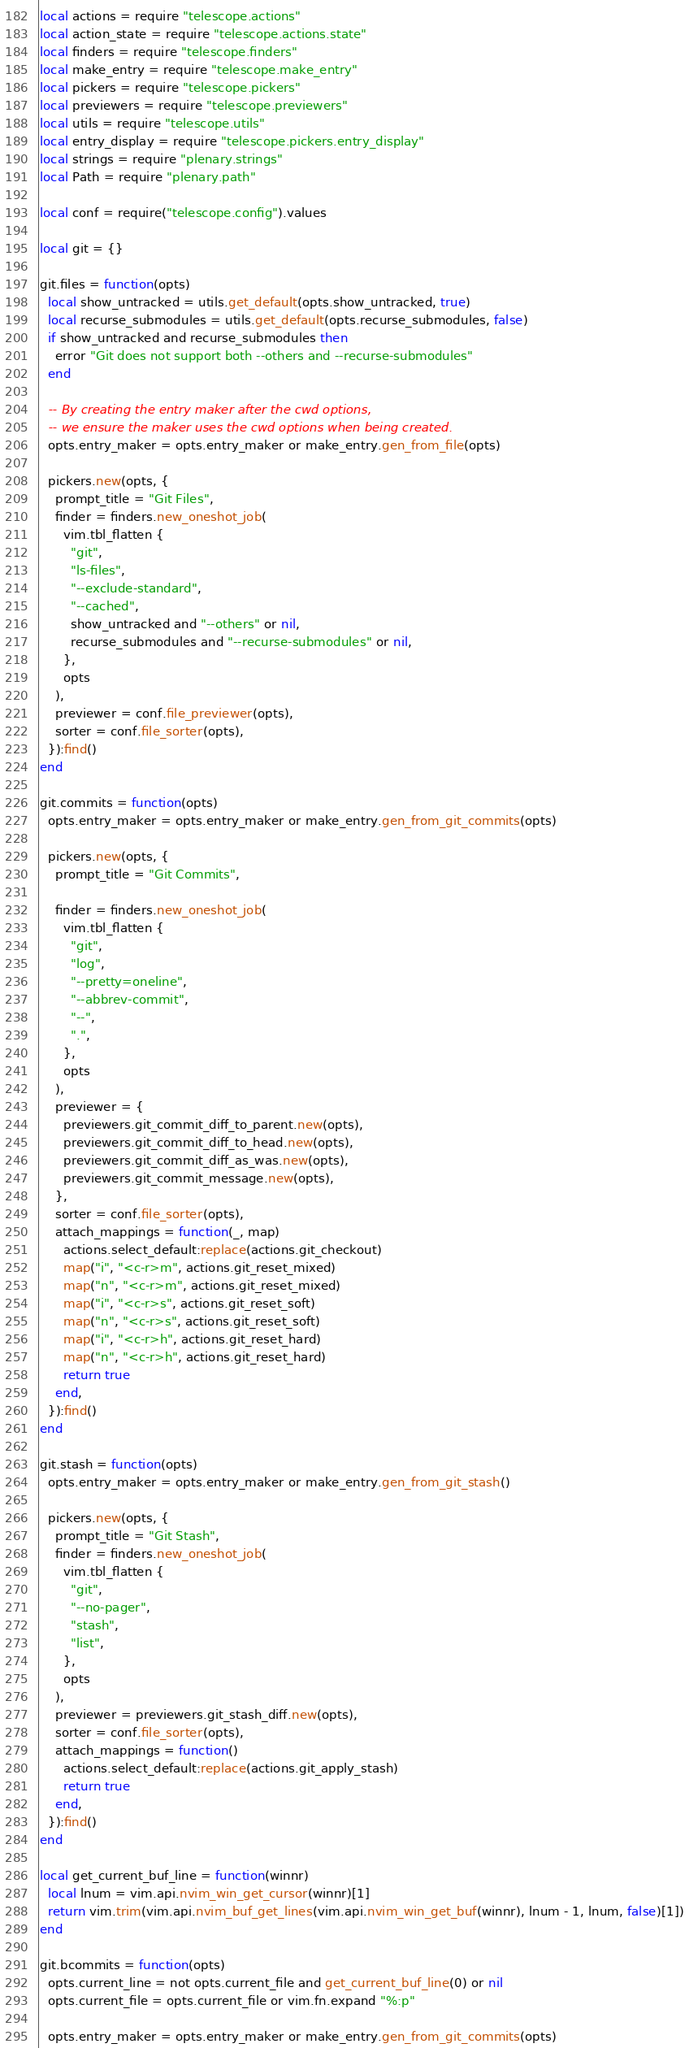Convert code to text. <code><loc_0><loc_0><loc_500><loc_500><_Lua_>local actions = require "telescope.actions"
local action_state = require "telescope.actions.state"
local finders = require "telescope.finders"
local make_entry = require "telescope.make_entry"
local pickers = require "telescope.pickers"
local previewers = require "telescope.previewers"
local utils = require "telescope.utils"
local entry_display = require "telescope.pickers.entry_display"
local strings = require "plenary.strings"
local Path = require "plenary.path"

local conf = require("telescope.config").values

local git = {}

git.files = function(opts)
  local show_untracked = utils.get_default(opts.show_untracked, true)
  local recurse_submodules = utils.get_default(opts.recurse_submodules, false)
  if show_untracked and recurse_submodules then
    error "Git does not support both --others and --recurse-submodules"
  end

  -- By creating the entry maker after the cwd options,
  -- we ensure the maker uses the cwd options when being created.
  opts.entry_maker = opts.entry_maker or make_entry.gen_from_file(opts)

  pickers.new(opts, {
    prompt_title = "Git Files",
    finder = finders.new_oneshot_job(
      vim.tbl_flatten {
        "git",
        "ls-files",
        "--exclude-standard",
        "--cached",
        show_untracked and "--others" or nil,
        recurse_submodules and "--recurse-submodules" or nil,
      },
      opts
    ),
    previewer = conf.file_previewer(opts),
    sorter = conf.file_sorter(opts),
  }):find()
end

git.commits = function(opts)
  opts.entry_maker = opts.entry_maker or make_entry.gen_from_git_commits(opts)

  pickers.new(opts, {
    prompt_title = "Git Commits",

    finder = finders.new_oneshot_job(
      vim.tbl_flatten {
        "git",
        "log",
        "--pretty=oneline",
        "--abbrev-commit",
        "--",
        ".",
      },
      opts
    ),
    previewer = {
      previewers.git_commit_diff_to_parent.new(opts),
      previewers.git_commit_diff_to_head.new(opts),
      previewers.git_commit_diff_as_was.new(opts),
      previewers.git_commit_message.new(opts),
    },
    sorter = conf.file_sorter(opts),
    attach_mappings = function(_, map)
      actions.select_default:replace(actions.git_checkout)
      map("i", "<c-r>m", actions.git_reset_mixed)
      map("n", "<c-r>m", actions.git_reset_mixed)
      map("i", "<c-r>s", actions.git_reset_soft)
      map("n", "<c-r>s", actions.git_reset_soft)
      map("i", "<c-r>h", actions.git_reset_hard)
      map("n", "<c-r>h", actions.git_reset_hard)
      return true
    end,
  }):find()
end

git.stash = function(opts)
  opts.entry_maker = opts.entry_maker or make_entry.gen_from_git_stash()

  pickers.new(opts, {
    prompt_title = "Git Stash",
    finder = finders.new_oneshot_job(
      vim.tbl_flatten {
        "git",
        "--no-pager",
        "stash",
        "list",
      },
      opts
    ),
    previewer = previewers.git_stash_diff.new(opts),
    sorter = conf.file_sorter(opts),
    attach_mappings = function()
      actions.select_default:replace(actions.git_apply_stash)
      return true
    end,
  }):find()
end

local get_current_buf_line = function(winnr)
  local lnum = vim.api.nvim_win_get_cursor(winnr)[1]
  return vim.trim(vim.api.nvim_buf_get_lines(vim.api.nvim_win_get_buf(winnr), lnum - 1, lnum, false)[1])
end

git.bcommits = function(opts)
  opts.current_line = not opts.current_file and get_current_buf_line(0) or nil
  opts.current_file = opts.current_file or vim.fn.expand "%:p"

  opts.entry_maker = opts.entry_maker or make_entry.gen_from_git_commits(opts)
</code> 